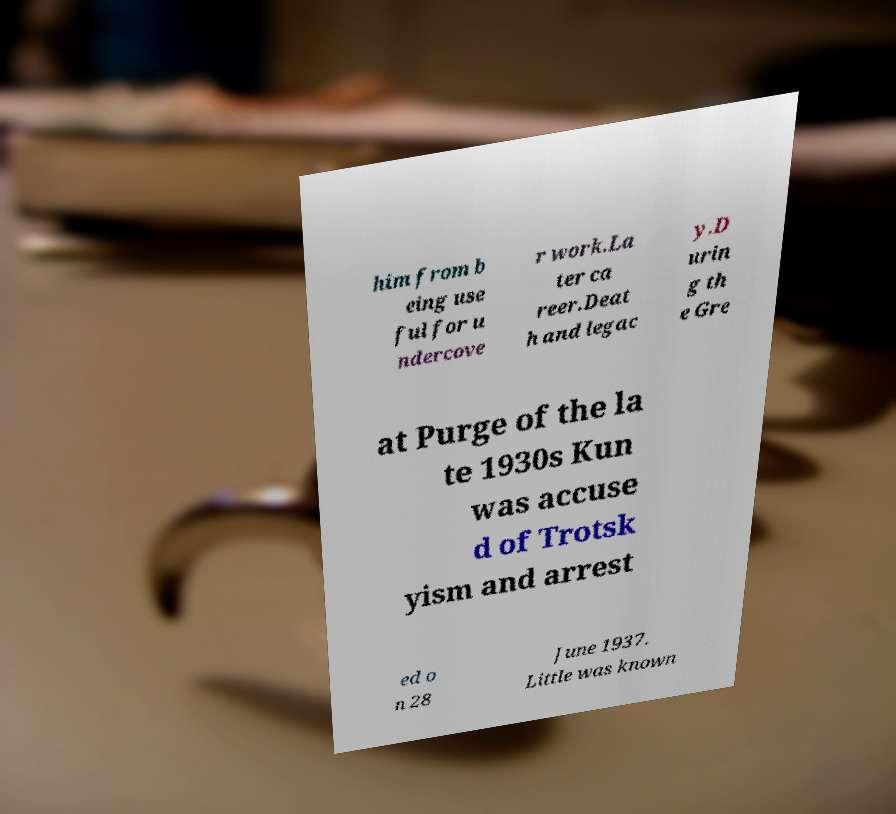I need the written content from this picture converted into text. Can you do that? him from b eing use ful for u ndercove r work.La ter ca reer.Deat h and legac y.D urin g th e Gre at Purge of the la te 1930s Kun was accuse d of Trotsk yism and arrest ed o n 28 June 1937. Little was known 